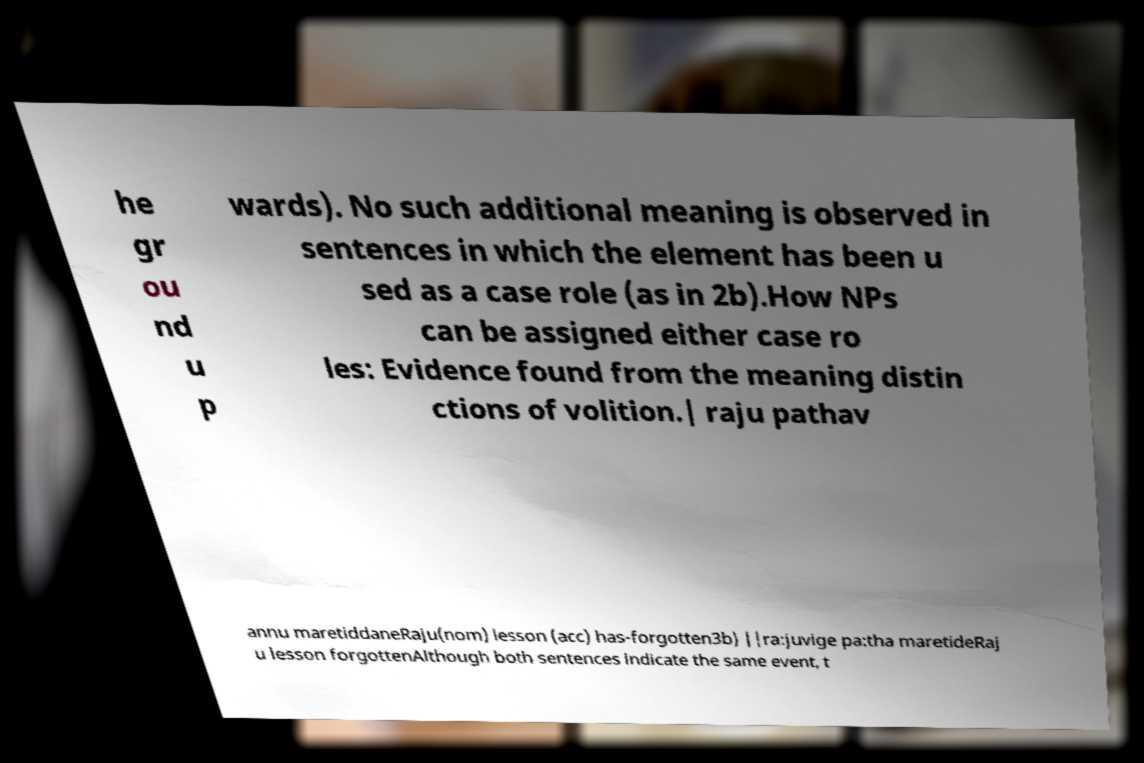Could you extract and type out the text from this image? he gr ou nd u p wards). No such additional meaning is observed in sentences in which the element has been u sed as a case role (as in 2b).How NPs can be assigned either case ro les: Evidence found from the meaning distin ctions of volition.| raju pathav annu maretiddaneRaju(nom) lesson (acc) has-forgotten3b) ||ra:juvige pa:tha maretideRaj u lesson forgottenAlthough both sentences indicate the same event, t 